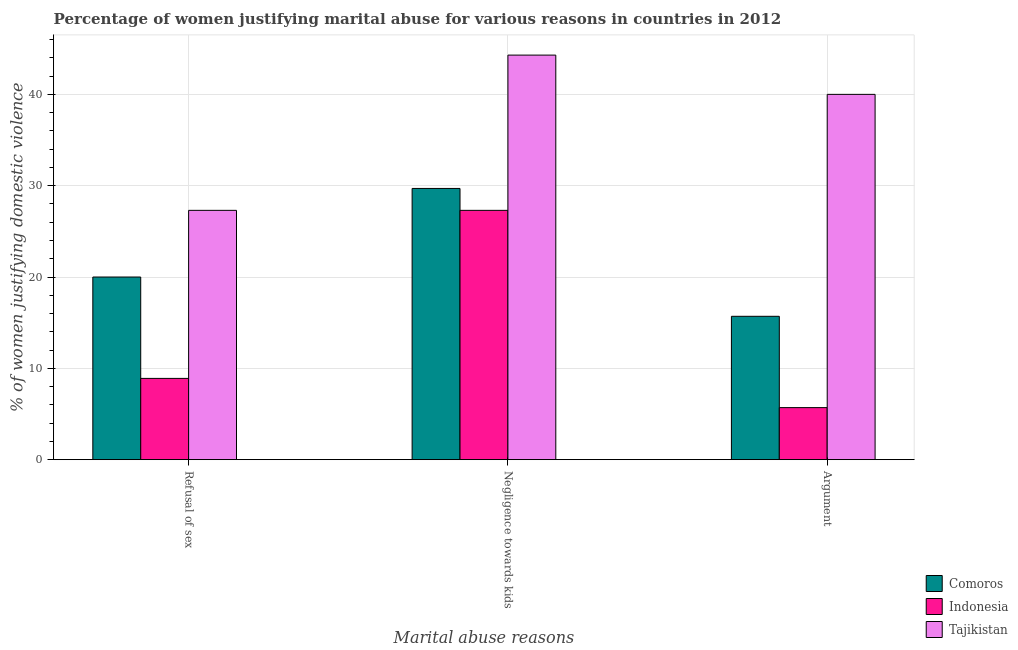Are the number of bars on each tick of the X-axis equal?
Give a very brief answer. Yes. How many bars are there on the 3rd tick from the left?
Give a very brief answer. 3. What is the label of the 3rd group of bars from the left?
Your answer should be very brief. Argument. What is the percentage of women justifying domestic violence due to negligence towards kids in Tajikistan?
Give a very brief answer. 44.3. Across all countries, what is the maximum percentage of women justifying domestic violence due to negligence towards kids?
Ensure brevity in your answer.  44.3. Across all countries, what is the minimum percentage of women justifying domestic violence due to negligence towards kids?
Keep it short and to the point. 27.3. In which country was the percentage of women justifying domestic violence due to negligence towards kids maximum?
Provide a short and direct response. Tajikistan. What is the total percentage of women justifying domestic violence due to negligence towards kids in the graph?
Your answer should be compact. 101.3. What is the difference between the percentage of women justifying domestic violence due to refusal of sex in Tajikistan and that in Comoros?
Offer a terse response. 7.3. What is the difference between the percentage of women justifying domestic violence due to negligence towards kids in Comoros and the percentage of women justifying domestic violence due to arguments in Tajikistan?
Your answer should be very brief. -10.3. What is the average percentage of women justifying domestic violence due to arguments per country?
Give a very brief answer. 20.47. What is the difference between the percentage of women justifying domestic violence due to negligence towards kids and percentage of women justifying domestic violence due to arguments in Tajikistan?
Offer a terse response. 4.3. What is the ratio of the percentage of women justifying domestic violence due to negligence towards kids in Comoros to that in Indonesia?
Ensure brevity in your answer.  1.09. Is the percentage of women justifying domestic violence due to arguments in Tajikistan less than that in Comoros?
Your answer should be very brief. No. Is the difference between the percentage of women justifying domestic violence due to refusal of sex in Comoros and Tajikistan greater than the difference between the percentage of women justifying domestic violence due to arguments in Comoros and Tajikistan?
Make the answer very short. Yes. What is the difference between the highest and the second highest percentage of women justifying domestic violence due to refusal of sex?
Ensure brevity in your answer.  7.3. What is the difference between the highest and the lowest percentage of women justifying domestic violence due to arguments?
Provide a short and direct response. 34.3. In how many countries, is the percentage of women justifying domestic violence due to refusal of sex greater than the average percentage of women justifying domestic violence due to refusal of sex taken over all countries?
Provide a succinct answer. 2. What does the 3rd bar from the left in Argument represents?
Ensure brevity in your answer.  Tajikistan. What does the 1st bar from the right in Argument represents?
Offer a very short reply. Tajikistan. Is it the case that in every country, the sum of the percentage of women justifying domestic violence due to refusal of sex and percentage of women justifying domestic violence due to negligence towards kids is greater than the percentage of women justifying domestic violence due to arguments?
Provide a short and direct response. Yes. How many bars are there?
Provide a short and direct response. 9. Are all the bars in the graph horizontal?
Offer a very short reply. No. What is the difference between two consecutive major ticks on the Y-axis?
Give a very brief answer. 10. Are the values on the major ticks of Y-axis written in scientific E-notation?
Your answer should be compact. No. Does the graph contain any zero values?
Ensure brevity in your answer.  No. Does the graph contain grids?
Your answer should be compact. Yes. How many legend labels are there?
Your answer should be very brief. 3. What is the title of the graph?
Offer a very short reply. Percentage of women justifying marital abuse for various reasons in countries in 2012. Does "Euro area" appear as one of the legend labels in the graph?
Provide a short and direct response. No. What is the label or title of the X-axis?
Provide a succinct answer. Marital abuse reasons. What is the label or title of the Y-axis?
Offer a very short reply. % of women justifying domestic violence. What is the % of women justifying domestic violence in Comoros in Refusal of sex?
Keep it short and to the point. 20. What is the % of women justifying domestic violence of Indonesia in Refusal of sex?
Your answer should be very brief. 8.9. What is the % of women justifying domestic violence of Tajikistan in Refusal of sex?
Give a very brief answer. 27.3. What is the % of women justifying domestic violence of Comoros in Negligence towards kids?
Provide a short and direct response. 29.7. What is the % of women justifying domestic violence of Indonesia in Negligence towards kids?
Give a very brief answer. 27.3. What is the % of women justifying domestic violence in Tajikistan in Negligence towards kids?
Your answer should be very brief. 44.3. What is the % of women justifying domestic violence in Comoros in Argument?
Keep it short and to the point. 15.7. What is the % of women justifying domestic violence of Indonesia in Argument?
Provide a succinct answer. 5.7. Across all Marital abuse reasons, what is the maximum % of women justifying domestic violence of Comoros?
Offer a very short reply. 29.7. Across all Marital abuse reasons, what is the maximum % of women justifying domestic violence of Indonesia?
Ensure brevity in your answer.  27.3. Across all Marital abuse reasons, what is the maximum % of women justifying domestic violence in Tajikistan?
Make the answer very short. 44.3. Across all Marital abuse reasons, what is the minimum % of women justifying domestic violence of Comoros?
Offer a terse response. 15.7. Across all Marital abuse reasons, what is the minimum % of women justifying domestic violence of Tajikistan?
Your response must be concise. 27.3. What is the total % of women justifying domestic violence of Comoros in the graph?
Your answer should be compact. 65.4. What is the total % of women justifying domestic violence in Indonesia in the graph?
Give a very brief answer. 41.9. What is the total % of women justifying domestic violence of Tajikistan in the graph?
Make the answer very short. 111.6. What is the difference between the % of women justifying domestic violence in Indonesia in Refusal of sex and that in Negligence towards kids?
Offer a very short reply. -18.4. What is the difference between the % of women justifying domestic violence of Tajikistan in Refusal of sex and that in Negligence towards kids?
Offer a very short reply. -17. What is the difference between the % of women justifying domestic violence of Tajikistan in Refusal of sex and that in Argument?
Provide a succinct answer. -12.7. What is the difference between the % of women justifying domestic violence in Indonesia in Negligence towards kids and that in Argument?
Ensure brevity in your answer.  21.6. What is the difference between the % of women justifying domestic violence of Tajikistan in Negligence towards kids and that in Argument?
Keep it short and to the point. 4.3. What is the difference between the % of women justifying domestic violence of Comoros in Refusal of sex and the % of women justifying domestic violence of Indonesia in Negligence towards kids?
Make the answer very short. -7.3. What is the difference between the % of women justifying domestic violence in Comoros in Refusal of sex and the % of women justifying domestic violence in Tajikistan in Negligence towards kids?
Your answer should be very brief. -24.3. What is the difference between the % of women justifying domestic violence of Indonesia in Refusal of sex and the % of women justifying domestic violence of Tajikistan in Negligence towards kids?
Ensure brevity in your answer.  -35.4. What is the difference between the % of women justifying domestic violence in Comoros in Refusal of sex and the % of women justifying domestic violence in Tajikistan in Argument?
Make the answer very short. -20. What is the difference between the % of women justifying domestic violence of Indonesia in Refusal of sex and the % of women justifying domestic violence of Tajikistan in Argument?
Ensure brevity in your answer.  -31.1. What is the difference between the % of women justifying domestic violence in Comoros in Negligence towards kids and the % of women justifying domestic violence in Indonesia in Argument?
Your answer should be very brief. 24. What is the difference between the % of women justifying domestic violence in Comoros in Negligence towards kids and the % of women justifying domestic violence in Tajikistan in Argument?
Give a very brief answer. -10.3. What is the difference between the % of women justifying domestic violence of Indonesia in Negligence towards kids and the % of women justifying domestic violence of Tajikistan in Argument?
Your answer should be compact. -12.7. What is the average % of women justifying domestic violence of Comoros per Marital abuse reasons?
Your answer should be very brief. 21.8. What is the average % of women justifying domestic violence of Indonesia per Marital abuse reasons?
Keep it short and to the point. 13.97. What is the average % of women justifying domestic violence in Tajikistan per Marital abuse reasons?
Ensure brevity in your answer.  37.2. What is the difference between the % of women justifying domestic violence in Indonesia and % of women justifying domestic violence in Tajikistan in Refusal of sex?
Give a very brief answer. -18.4. What is the difference between the % of women justifying domestic violence of Comoros and % of women justifying domestic violence of Tajikistan in Negligence towards kids?
Your response must be concise. -14.6. What is the difference between the % of women justifying domestic violence of Indonesia and % of women justifying domestic violence of Tajikistan in Negligence towards kids?
Offer a terse response. -17. What is the difference between the % of women justifying domestic violence in Comoros and % of women justifying domestic violence in Tajikistan in Argument?
Offer a very short reply. -24.3. What is the difference between the % of women justifying domestic violence of Indonesia and % of women justifying domestic violence of Tajikistan in Argument?
Your answer should be very brief. -34.3. What is the ratio of the % of women justifying domestic violence in Comoros in Refusal of sex to that in Negligence towards kids?
Make the answer very short. 0.67. What is the ratio of the % of women justifying domestic violence of Indonesia in Refusal of sex to that in Negligence towards kids?
Ensure brevity in your answer.  0.33. What is the ratio of the % of women justifying domestic violence of Tajikistan in Refusal of sex to that in Negligence towards kids?
Your response must be concise. 0.62. What is the ratio of the % of women justifying domestic violence in Comoros in Refusal of sex to that in Argument?
Offer a terse response. 1.27. What is the ratio of the % of women justifying domestic violence of Indonesia in Refusal of sex to that in Argument?
Keep it short and to the point. 1.56. What is the ratio of the % of women justifying domestic violence of Tajikistan in Refusal of sex to that in Argument?
Make the answer very short. 0.68. What is the ratio of the % of women justifying domestic violence in Comoros in Negligence towards kids to that in Argument?
Keep it short and to the point. 1.89. What is the ratio of the % of women justifying domestic violence in Indonesia in Negligence towards kids to that in Argument?
Keep it short and to the point. 4.79. What is the ratio of the % of women justifying domestic violence in Tajikistan in Negligence towards kids to that in Argument?
Give a very brief answer. 1.11. What is the difference between the highest and the second highest % of women justifying domestic violence of Comoros?
Offer a very short reply. 9.7. What is the difference between the highest and the second highest % of women justifying domestic violence in Indonesia?
Provide a succinct answer. 18.4. What is the difference between the highest and the second highest % of women justifying domestic violence of Tajikistan?
Make the answer very short. 4.3. What is the difference between the highest and the lowest % of women justifying domestic violence in Comoros?
Your response must be concise. 14. What is the difference between the highest and the lowest % of women justifying domestic violence in Indonesia?
Make the answer very short. 21.6. What is the difference between the highest and the lowest % of women justifying domestic violence of Tajikistan?
Offer a terse response. 17. 